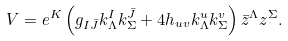Convert formula to latex. <formula><loc_0><loc_0><loc_500><loc_500>V = e ^ { K } \left ( g _ { I \bar { J } } k ^ { I } _ { \Lambda } k ^ { \bar { J } } _ { \Sigma } + 4 h _ { u v } k ^ { u } _ { \Lambda } k ^ { v } _ { \Sigma } \right ) \bar { z } ^ { \Lambda } z ^ { \Sigma } .</formula> 